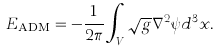<formula> <loc_0><loc_0><loc_500><loc_500>E _ { \text {ADM} } = - \frac { 1 } { 2 \pi } \int _ { V } \sqrt { g } \nabla ^ { 2 } \psi d ^ { 3 } x .</formula> 